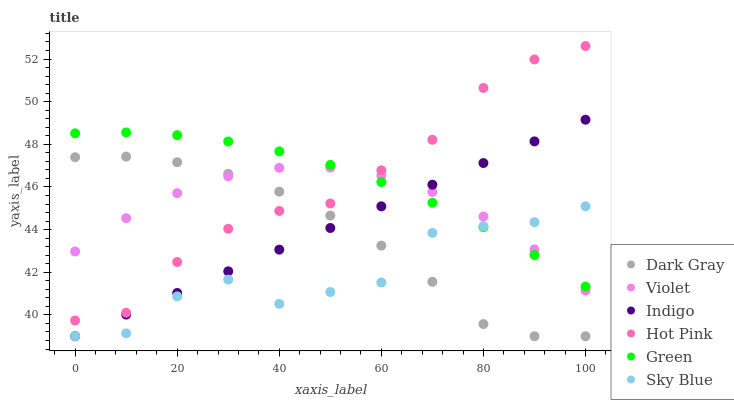Does Sky Blue have the minimum area under the curve?
Answer yes or no. Yes. Does Green have the maximum area under the curve?
Answer yes or no. Yes. Does Hot Pink have the minimum area under the curve?
Answer yes or no. No. Does Hot Pink have the maximum area under the curve?
Answer yes or no. No. Is Indigo the smoothest?
Answer yes or no. Yes. Is Sky Blue the roughest?
Answer yes or no. Yes. Is Hot Pink the smoothest?
Answer yes or no. No. Is Hot Pink the roughest?
Answer yes or no. No. Does Indigo have the lowest value?
Answer yes or no. Yes. Does Hot Pink have the lowest value?
Answer yes or no. No. Does Hot Pink have the highest value?
Answer yes or no. Yes. Does Dark Gray have the highest value?
Answer yes or no. No. Is Sky Blue less than Hot Pink?
Answer yes or no. Yes. Is Hot Pink greater than Sky Blue?
Answer yes or no. Yes. Does Indigo intersect Violet?
Answer yes or no. Yes. Is Indigo less than Violet?
Answer yes or no. No. Is Indigo greater than Violet?
Answer yes or no. No. Does Sky Blue intersect Hot Pink?
Answer yes or no. No. 